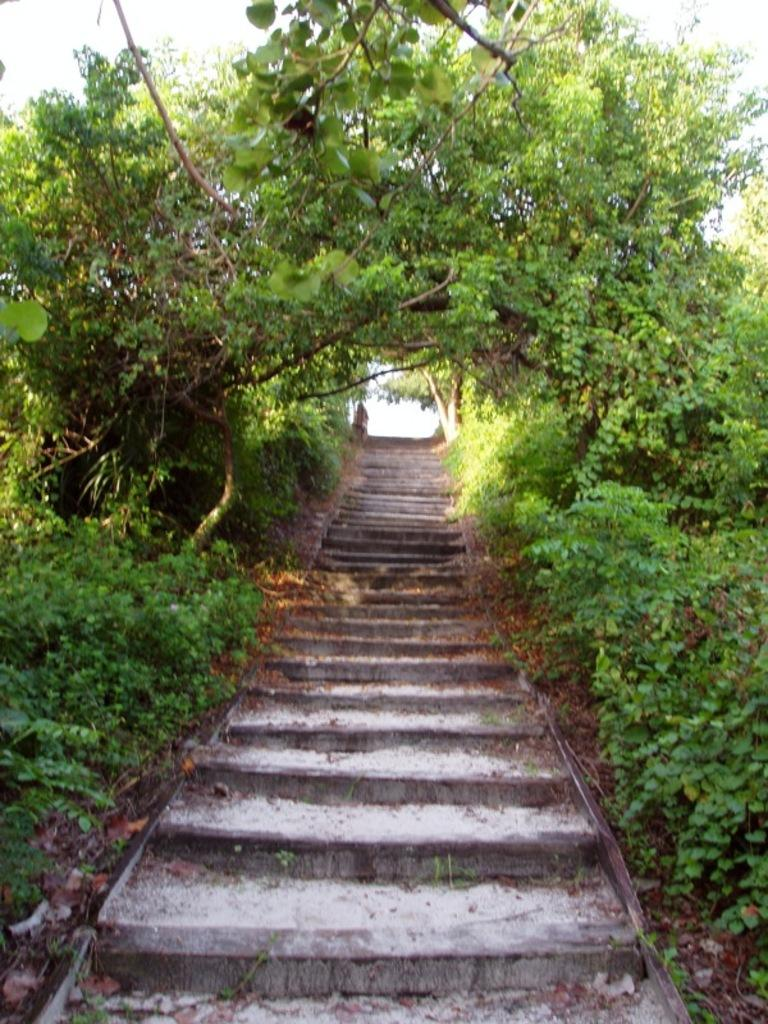What type of architectural feature is present in the image? There are steps in the image. What other elements can be seen in the image? There are plants in the image. What can be seen in the background of the image? The sky is visible in the background of the image. Is there a person involved in a fight in the image? There is no person or fight present in the image. What type of salt can be seen on the plants in the image? There is no salt present in the image; it only features steps, plants, and the sky. 